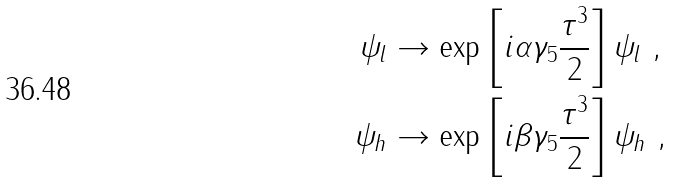Convert formula to latex. <formula><loc_0><loc_0><loc_500><loc_500>\psi _ { l } & \to \exp \left [ i \alpha \gamma _ { 5 } \frac { \tau ^ { 3 } } { 2 } \right ] \psi _ { l } \ , \\ \psi _ { h } & \to \exp \left [ i \beta \gamma _ { 5 } \frac { \tau ^ { 3 } } { 2 } \right ] \psi _ { h } \ ,</formula> 